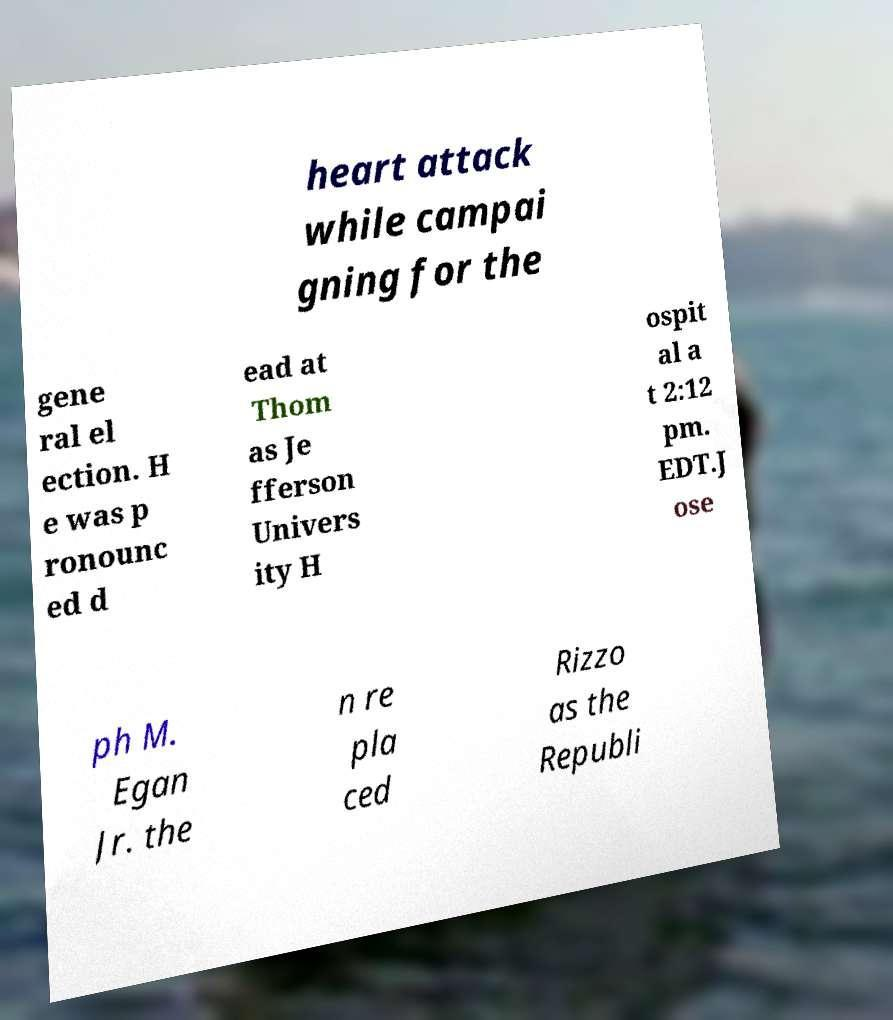Can you read and provide the text displayed in the image?This photo seems to have some interesting text. Can you extract and type it out for me? heart attack while campai gning for the gene ral el ection. H e was p ronounc ed d ead at Thom as Je fferson Univers ity H ospit al a t 2:12 pm. EDT.J ose ph M. Egan Jr. the n re pla ced Rizzo as the Republi 